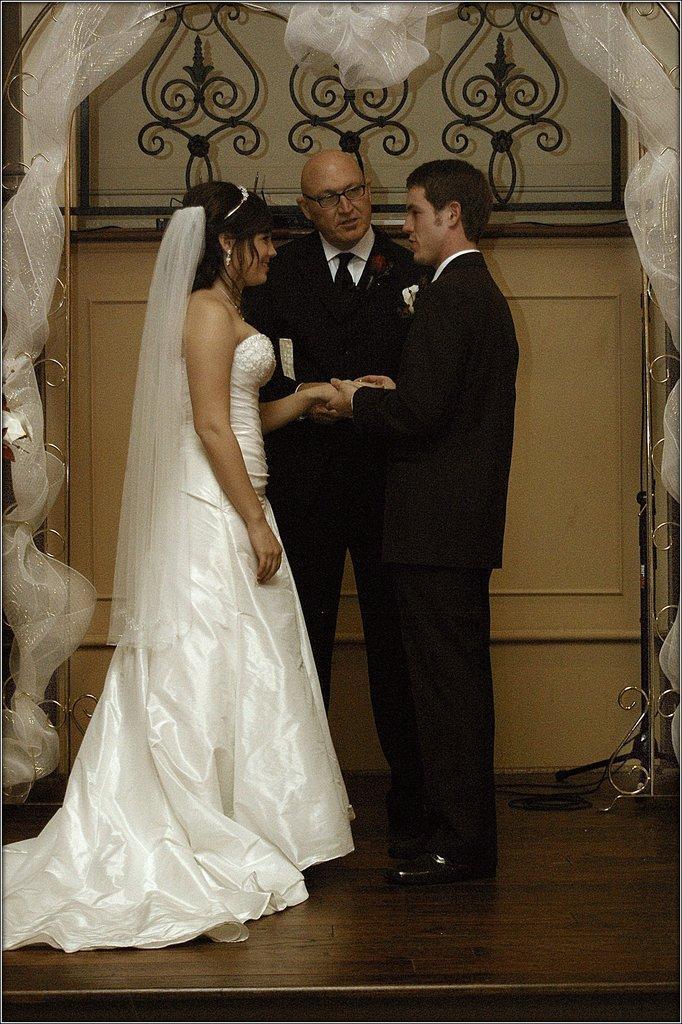Please provide a concise description of this image. In this image there is a couple standing and the person holding the hand of the girl, behind them there is another person. In the background there is a wall with decoration. 